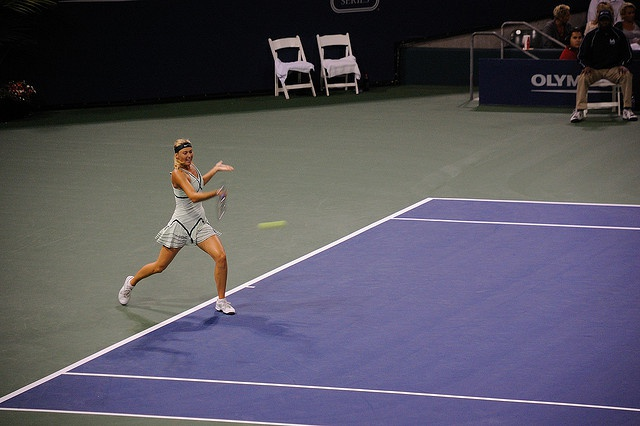Describe the objects in this image and their specific colors. I can see people in black, darkgray, brown, and gray tones, people in black, gray, and maroon tones, chair in black, darkgray, and gray tones, chair in black, darkgray, and gray tones, and chair in black, gray, and darkgray tones in this image. 